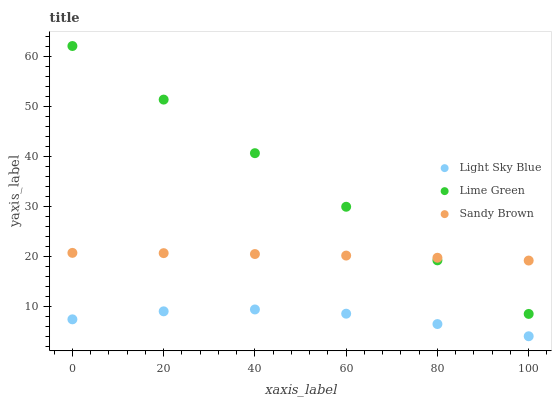Does Light Sky Blue have the minimum area under the curve?
Answer yes or no. Yes. Does Lime Green have the maximum area under the curve?
Answer yes or no. Yes. Does Lime Green have the minimum area under the curve?
Answer yes or no. No. Does Light Sky Blue have the maximum area under the curve?
Answer yes or no. No. Is Lime Green the smoothest?
Answer yes or no. Yes. Is Light Sky Blue the roughest?
Answer yes or no. Yes. Is Light Sky Blue the smoothest?
Answer yes or no. No. Is Lime Green the roughest?
Answer yes or no. No. Does Light Sky Blue have the lowest value?
Answer yes or no. Yes. Does Lime Green have the lowest value?
Answer yes or no. No. Does Lime Green have the highest value?
Answer yes or no. Yes. Does Light Sky Blue have the highest value?
Answer yes or no. No. Is Light Sky Blue less than Sandy Brown?
Answer yes or no. Yes. Is Lime Green greater than Light Sky Blue?
Answer yes or no. Yes. Does Sandy Brown intersect Lime Green?
Answer yes or no. Yes. Is Sandy Brown less than Lime Green?
Answer yes or no. No. Is Sandy Brown greater than Lime Green?
Answer yes or no. No. Does Light Sky Blue intersect Sandy Brown?
Answer yes or no. No. 